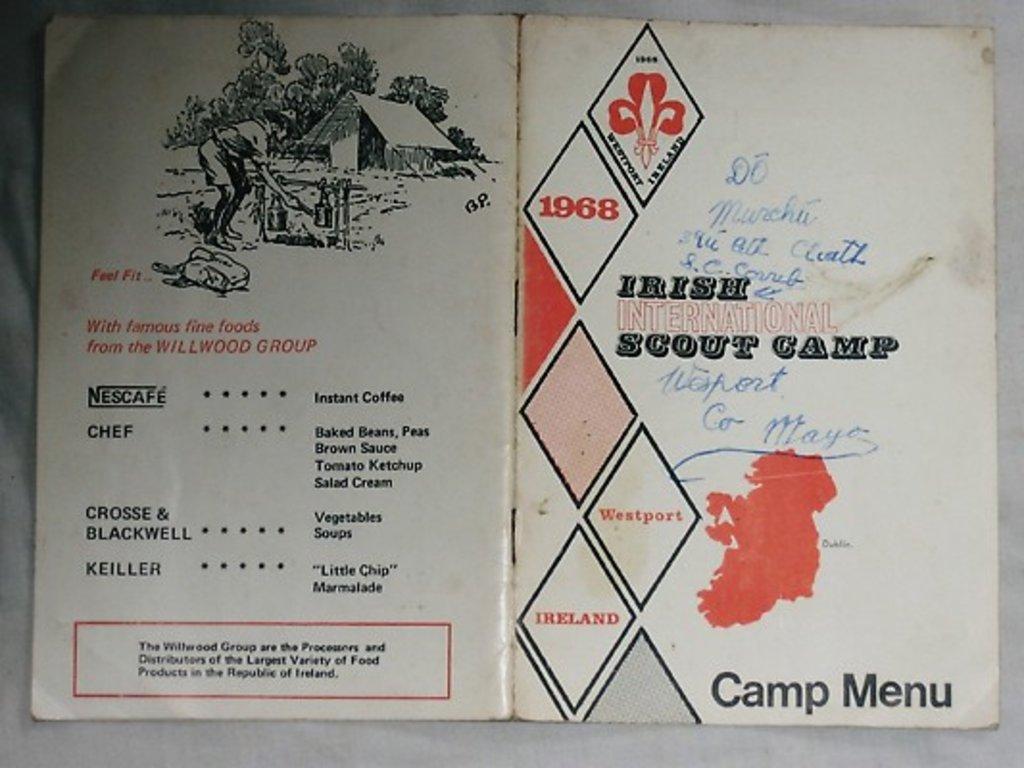In one or two sentences, can you explain what this image depicts? In this image, we can see a poster with some text and images is placed on the white colored surface. 